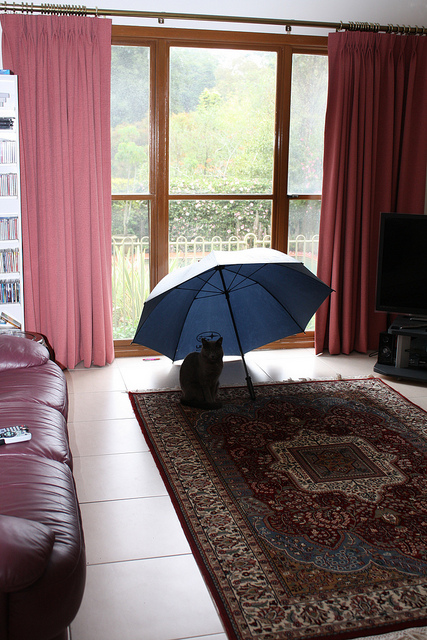Describe the setting where the cat is sitting. The cat is sitting on a traditional patterned rug in a cozy living room. There is a large brown leather sofa to the left, and a television set across the room. Large windows with pink curtains offer a view of trees and greenery outside, giving the room a serene atmosphere. 